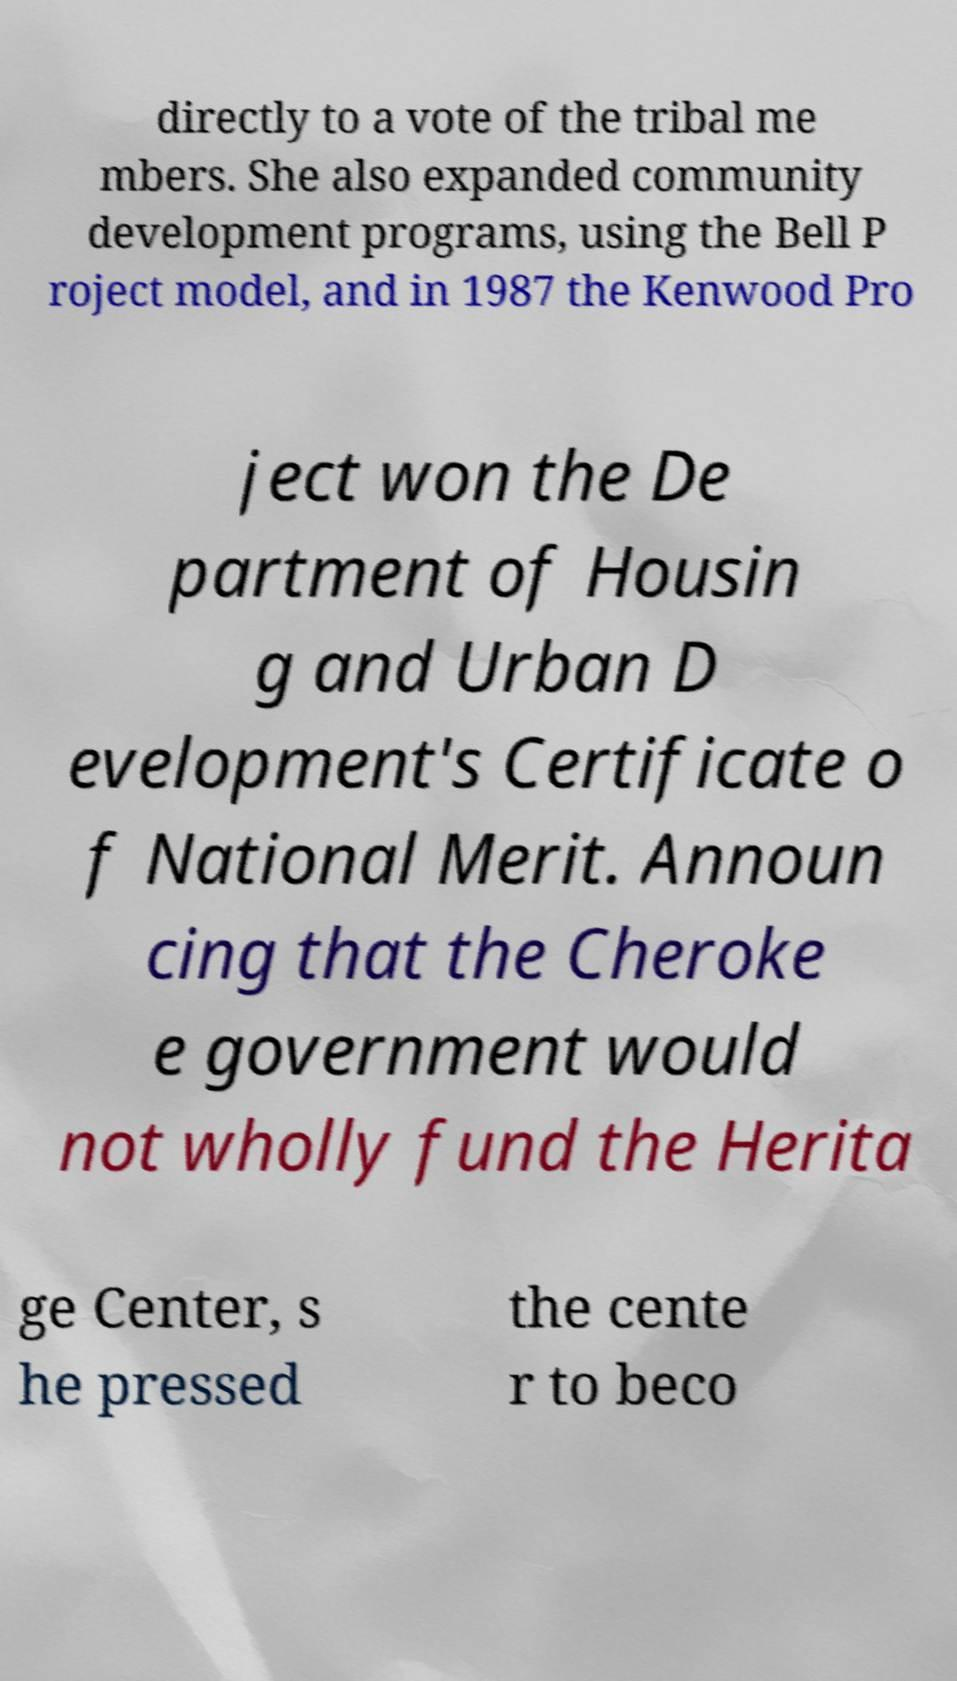There's text embedded in this image that I need extracted. Can you transcribe it verbatim? directly to a vote of the tribal me mbers. She also expanded community development programs, using the Bell P roject model, and in 1987 the Kenwood Pro ject won the De partment of Housin g and Urban D evelopment's Certificate o f National Merit. Announ cing that the Cheroke e government would not wholly fund the Herita ge Center, s he pressed the cente r to beco 